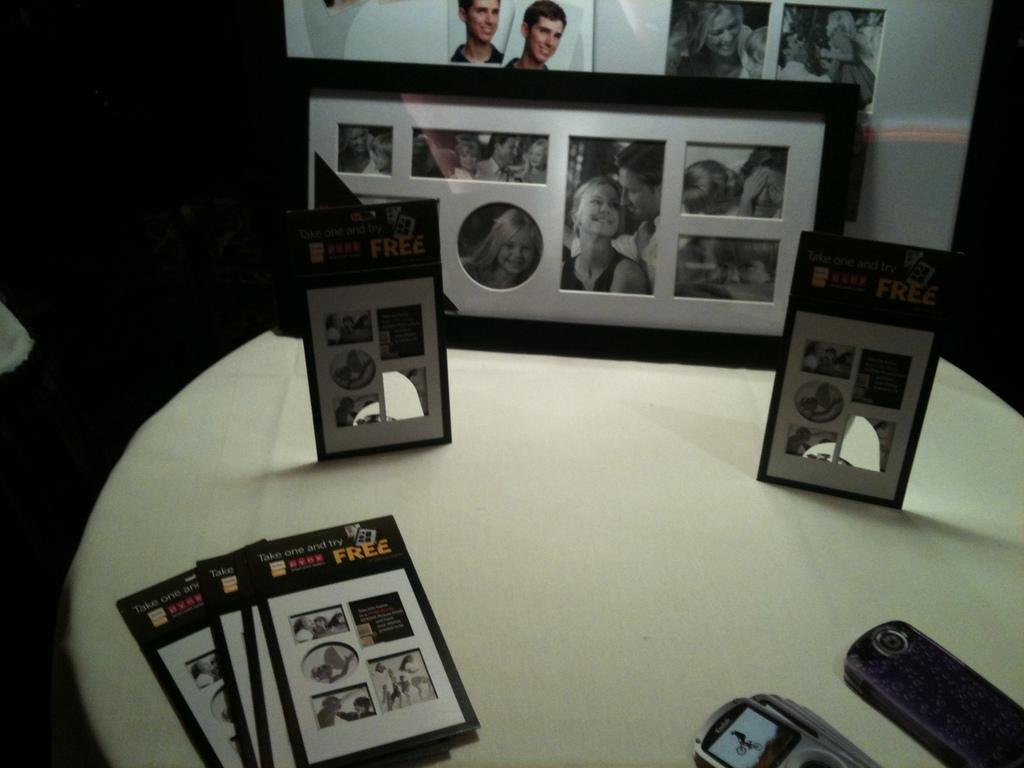<image>
Summarize the visual content of the image. On a table is photos with a upper area with the word free. 